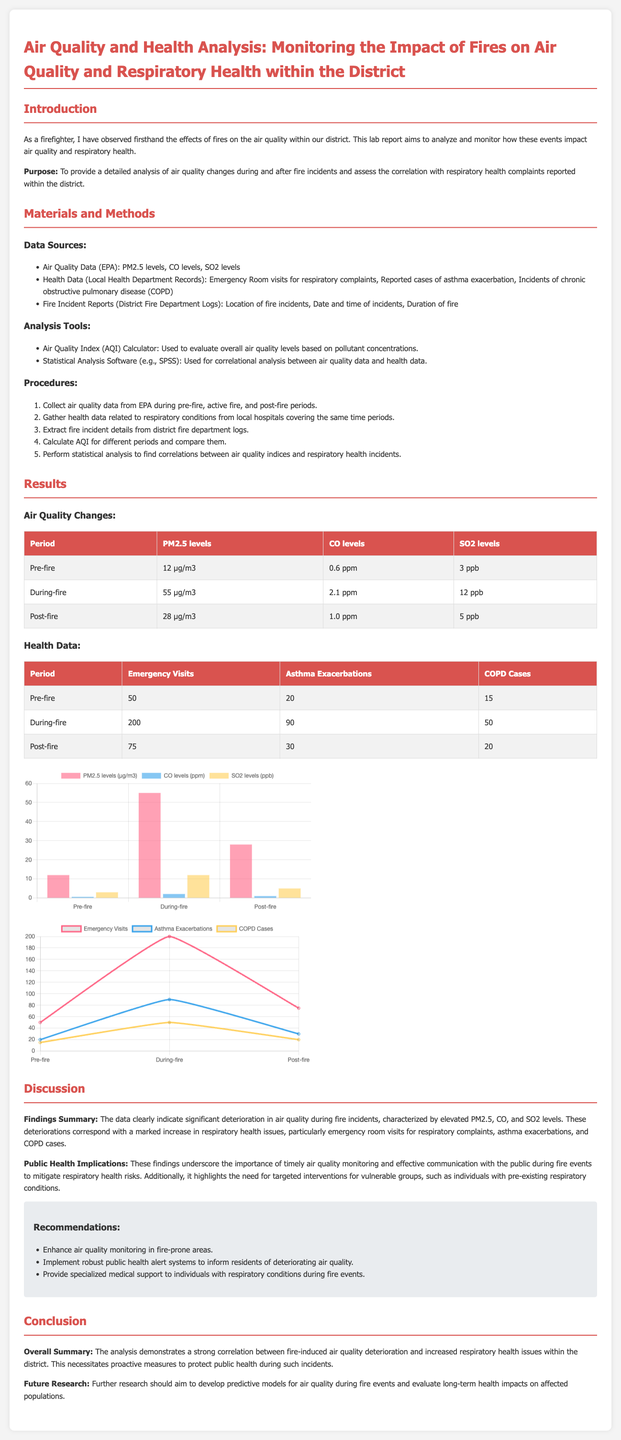What is the purpose of the report? The purpose is to provide a detailed analysis of air quality changes during and after fire incidents and assess the correlation with respiratory health complaints.
Answer: To provide a detailed analysis of air quality changes during and after fire incidents and assess the correlation with respiratory health complaints What was the PM2.5 level during the fire? The PM2.5 level during the fire is directly stated in the results table under "During-fire."
Answer: 55 µg/m3 What is the increase in emergency room visits during the fire? To find the increase, subtract the pre-fire visits from the during-fire visits (200 - 50).
Answer: 150 Which pollutant level decreased post-fire compared to during-fire? The comparison between post-fire and during-fire pollutant levels shows a decrease in that specific pollutant.
Answer: PM2.5 levels What is the total number of asthma exacerbations reported post-fire? The document specifies the number of asthma exacerbations for the post-fire period in the health data table.
Answer: 30 What does the AQI Calculator evaluate? The AQI Calculator evaluates overall air quality levels based on pollutant concentrations.
Answer: Overall air quality levels How many recommendations are listed in the report? The recommendations section provides a clear numerical answer by counting the list items.
Answer: Three What should future research focus on, according to the report? The report mentions future research should aim for specifics to develop predictive models and evaluate long-term health impacts.
Answer: Predictive models for air quality during fire events 